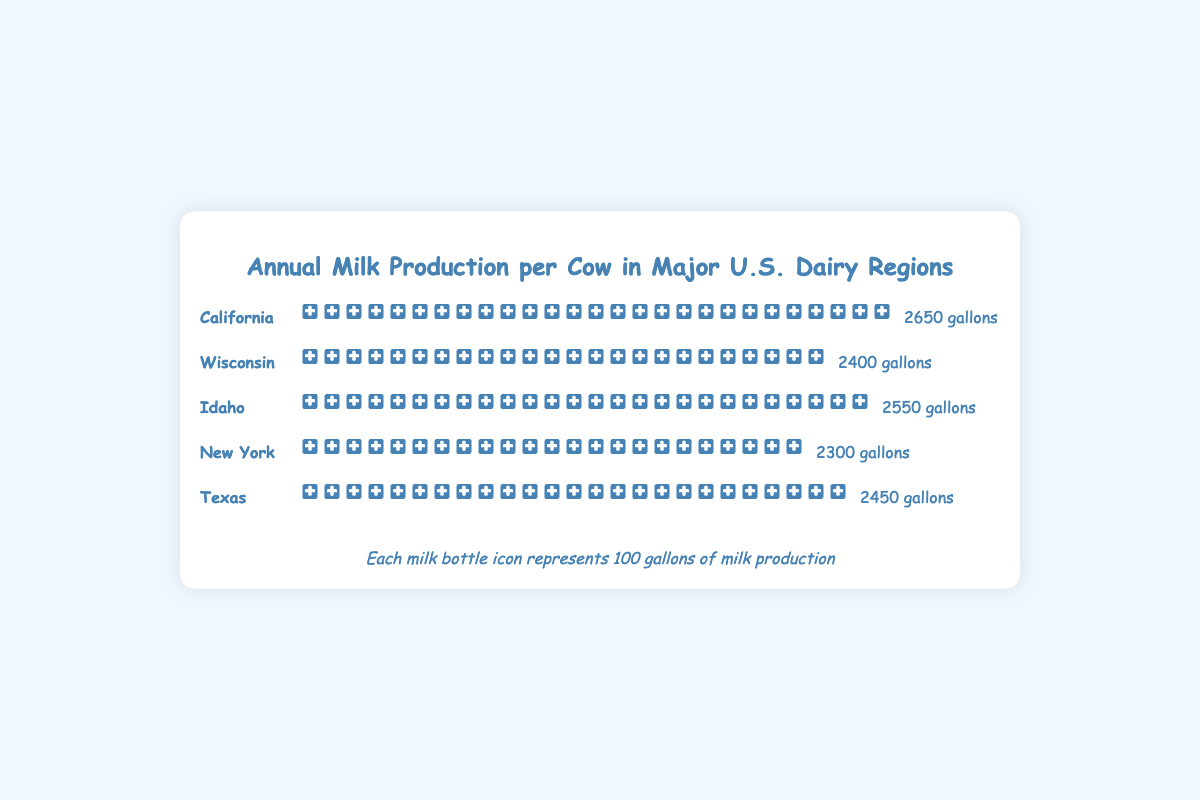What's the title of the chart? The title appears prominently at the top of the chart, and it reads "Annual Milk Production per Cow in Major U.S. Dairy Regions".
Answer: Annual Milk Production per Cow in Major U.S. Dairy Regions What icon is used to represent the milk production? Each milk bottle icon represents the milk production and stands for 100 gallons.
Answer: Milk bottle Which region has the highest milk production per cow? By counting the number of milk bottle icons, California has the highest with 27 icons (2650 gallons).
Answer: California How many gallons of milk does a cow produce in New York annually? Each milk bottle icon represents 100 gallons, and New York has 23 icons, which equates to 2300 gallons.
Answer: 2300 gallons How much more milk does a cow in California produce compared to a cow in Wisconsin? California produces 2650 gallons, while Wisconsin produces 2400 gallons. The difference is 2650 - 2400 = 250 gallons.
Answer: 250 gallons What is the total annual milk production per cow for all the listed regions combined? Sum up the production from all regions: 2650 (California) + 2400 (Wisconsin) + 2550 (Idaho) + 2300 (New York) + 2450 (Texas) = 12350 gallons.
Answer: 12350 gallons Which region has the least milk production per cow? Count the number of icons for each region and find that New York has the least with 23 icons, representing 2300 gallons.
Answer: New York What’s the average milk production per cow across all regions? Calculate the average by summing the productions and dividing by the number of regions: (2650 + 2400 + 2550 + 2300 + 2450) / 5 = 2470 gallons.
Answer: 2470 gallons How many milk bottle icons are used for Idaho's milk production? Each icon represents 100 gallons, and for Idaho at 2550 gallons, there are 26 icons (25 full icons and 1 half icon).
Answer: 26 Compare the milk production between Texas and Idaho. Which state produces more milk per cow, and by how much? Texas produces 2450 gallons, while Idaho produces 2550 gallons. Idaho produces more milk by 2550 - 2450 = 100 gallons.
Answer: Idaho, 100 gallons 